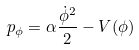<formula> <loc_0><loc_0><loc_500><loc_500>p _ { \phi } = \alpha \frac { \dot { \phi } ^ { 2 } } { 2 } - V ( \phi )</formula> 